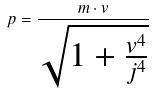<formula> <loc_0><loc_0><loc_500><loc_500>p = \frac { m \cdot v } { \sqrt { 1 + \frac { v ^ { 4 } } { j ^ { 4 } } } }</formula> 